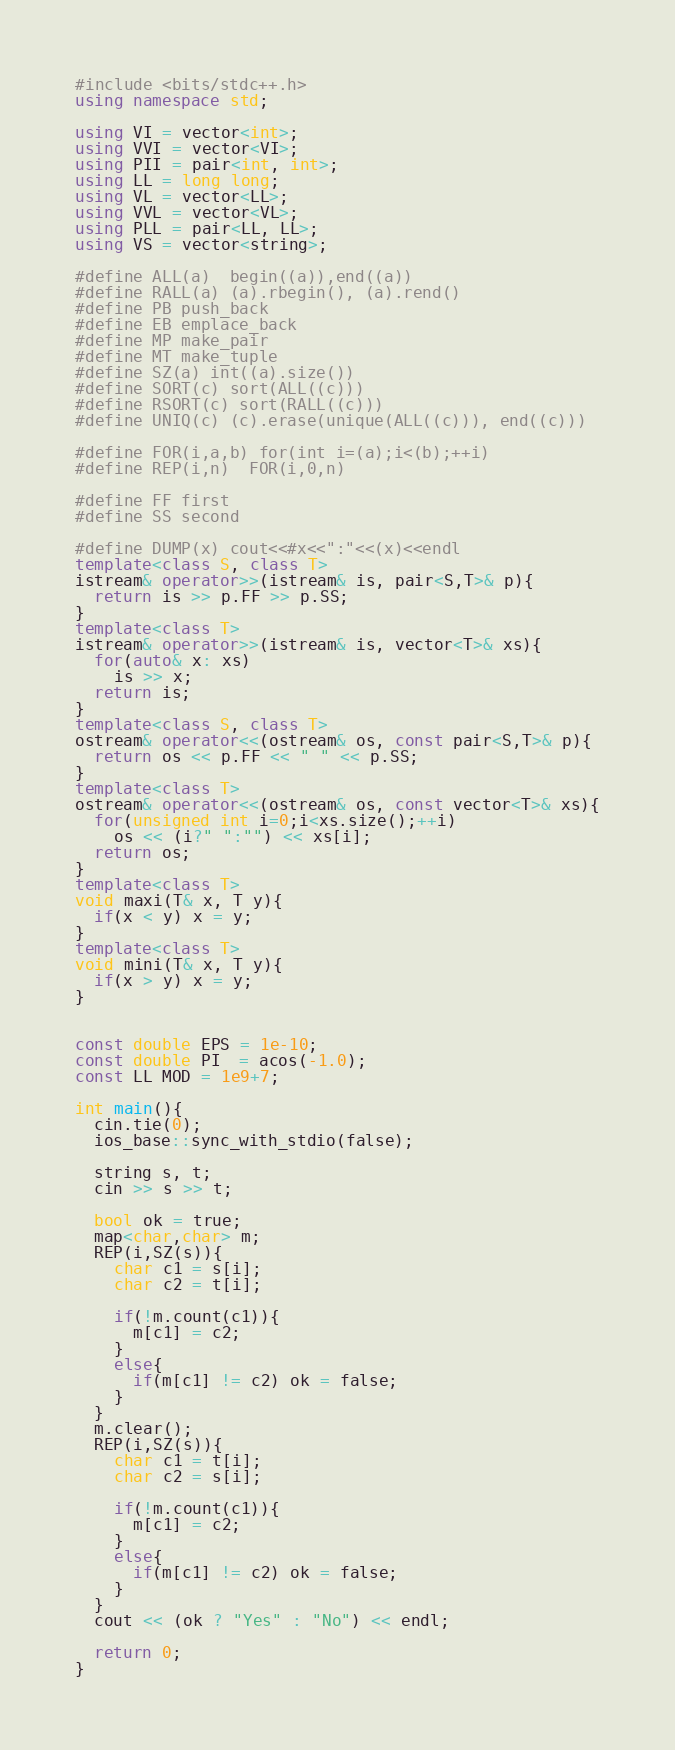<code> <loc_0><loc_0><loc_500><loc_500><_C++_>#include <bits/stdc++.h>
using namespace std;

using VI = vector<int>;
using VVI = vector<VI>;
using PII = pair<int, int>;
using LL = long long;
using VL = vector<LL>;
using VVL = vector<VL>;
using PLL = pair<LL, LL>;
using VS = vector<string>;

#define ALL(a)  begin((a)),end((a))
#define RALL(a) (a).rbegin(), (a).rend()
#define PB push_back
#define EB emplace_back
#define MP make_pair
#define MT make_tuple
#define SZ(a) int((a).size())
#define SORT(c) sort(ALL((c)))
#define RSORT(c) sort(RALL((c)))
#define UNIQ(c) (c).erase(unique(ALL((c))), end((c)))

#define FOR(i,a,b) for(int i=(a);i<(b);++i)
#define REP(i,n)  FOR(i,0,n)

#define FF first
#define SS second

#define DUMP(x) cout<<#x<<":"<<(x)<<endl
template<class S, class T>
istream& operator>>(istream& is, pair<S,T>& p){
  return is >> p.FF >> p.SS;
}
template<class T>
istream& operator>>(istream& is, vector<T>& xs){
  for(auto& x: xs)
	is >> x;
  return is;
}
template<class S, class T>
ostream& operator<<(ostream& os, const pair<S,T>& p){
  return os << p.FF << " " << p.SS;
}
template<class T>
ostream& operator<<(ostream& os, const vector<T>& xs){
  for(unsigned int i=0;i<xs.size();++i)
	os << (i?" ":"") << xs[i];
  return os;
}
template<class T>
void maxi(T& x, T y){
  if(x < y) x = y;
}
template<class T>
void mini(T& x, T y){
  if(x > y) x = y;
}


const double EPS = 1e-10;
const double PI  = acos(-1.0);
const LL MOD = 1e9+7;

int main(){
  cin.tie(0);
  ios_base::sync_with_stdio(false);

  string s, t;
  cin >> s >> t;

  bool ok = true;
  map<char,char> m;
  REP(i,SZ(s)){
    char c1 = s[i];
    char c2 = t[i];

    if(!m.count(c1)){
      m[c1] = c2;
    }
    else{
      if(m[c1] != c2) ok = false;
    }
  }
  m.clear();
  REP(i,SZ(s)){
    char c1 = t[i];
    char c2 = s[i];

    if(!m.count(c1)){
      m[c1] = c2;
    }
    else{
      if(m[c1] != c2) ok = false;
    }
  }
  cout << (ok ? "Yes" : "No") << endl;

  return 0;
}
</code> 